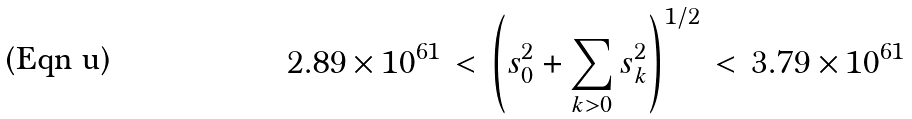Convert formula to latex. <formula><loc_0><loc_0><loc_500><loc_500>2 . 8 9 \times 1 0 ^ { 6 1 } \, < \, \left ( s _ { 0 } ^ { 2 } + \sum _ { k > 0 } s _ { k } ^ { 2 } \right ) ^ { 1 / 2 } \, < \, 3 . 7 9 \times 1 0 ^ { 6 1 }</formula> 